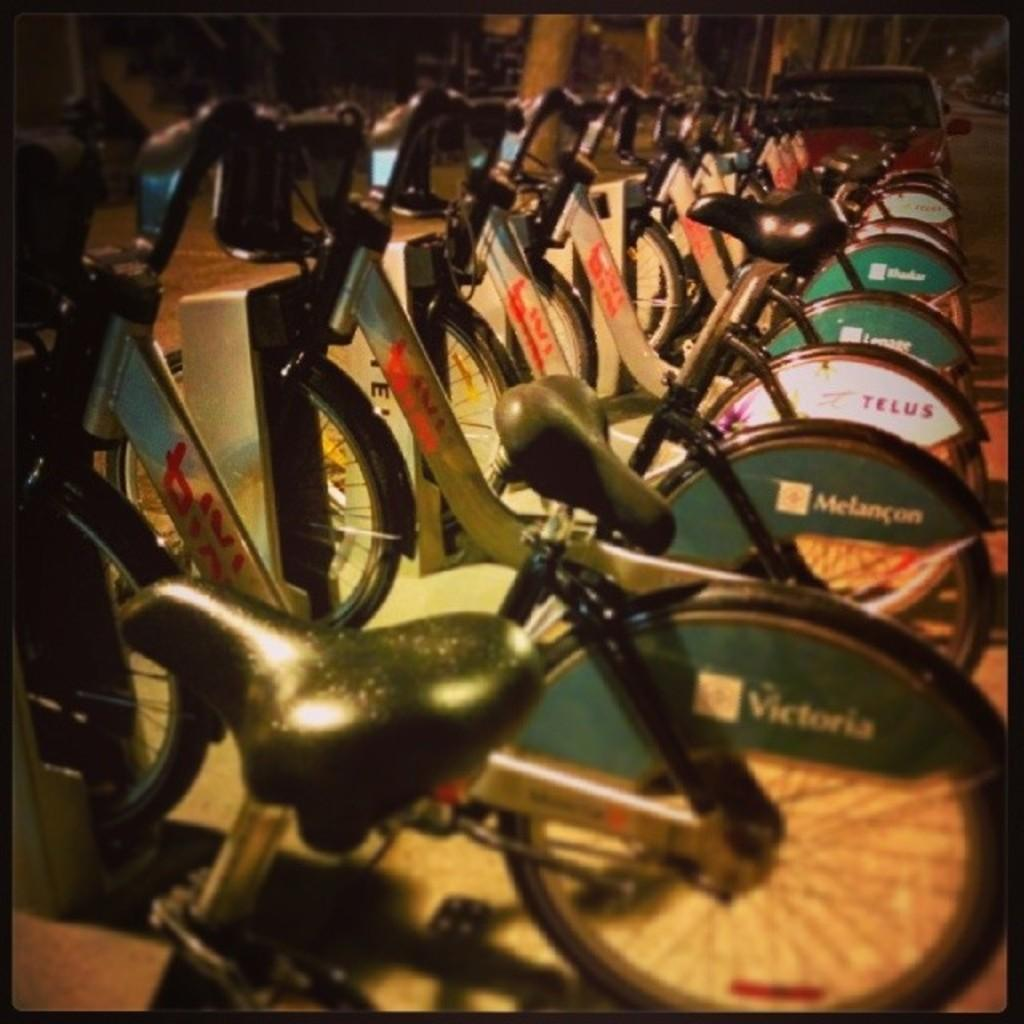What can be seen in the middle of the image? There are bicycles in the middle of the image. What is located behind the bicycles? There is a vehicle behind the bicycles. How many rabbits can be seen hopping around in the image? There are no rabbits present in the image. What type of weather condition is depicted in the image? The provided facts do not mention any weather conditions, so it cannot be determined from the image. 